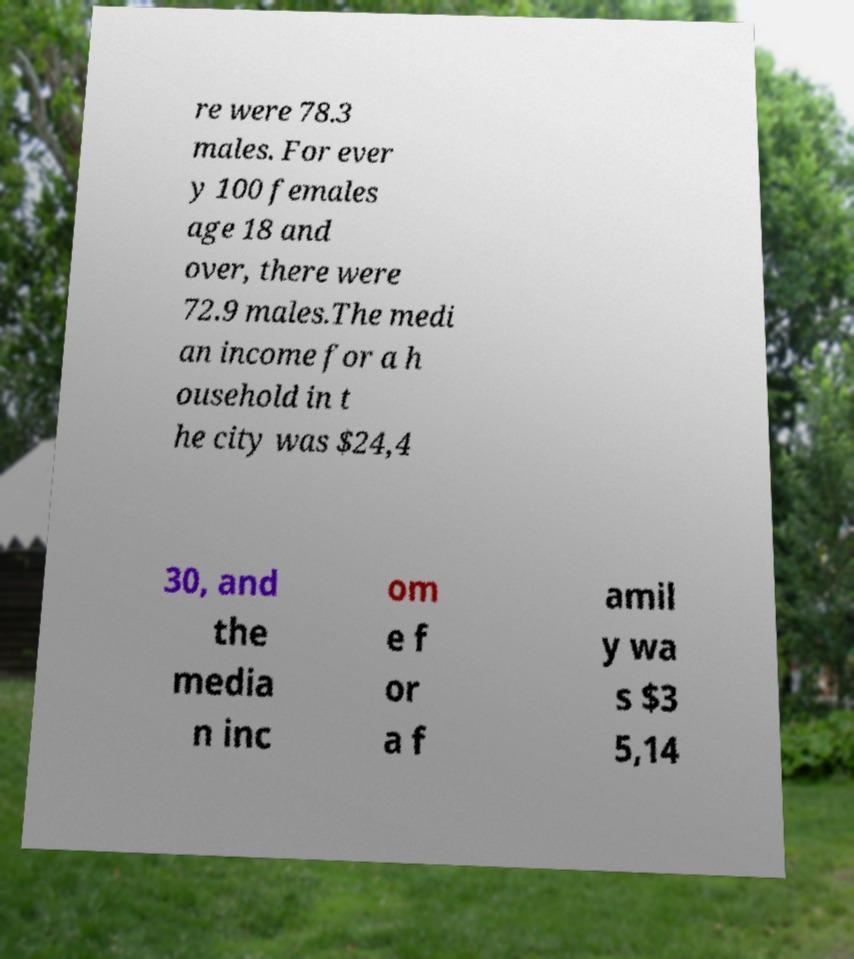There's text embedded in this image that I need extracted. Can you transcribe it verbatim? re were 78.3 males. For ever y 100 females age 18 and over, there were 72.9 males.The medi an income for a h ousehold in t he city was $24,4 30, and the media n inc om e f or a f amil y wa s $3 5,14 